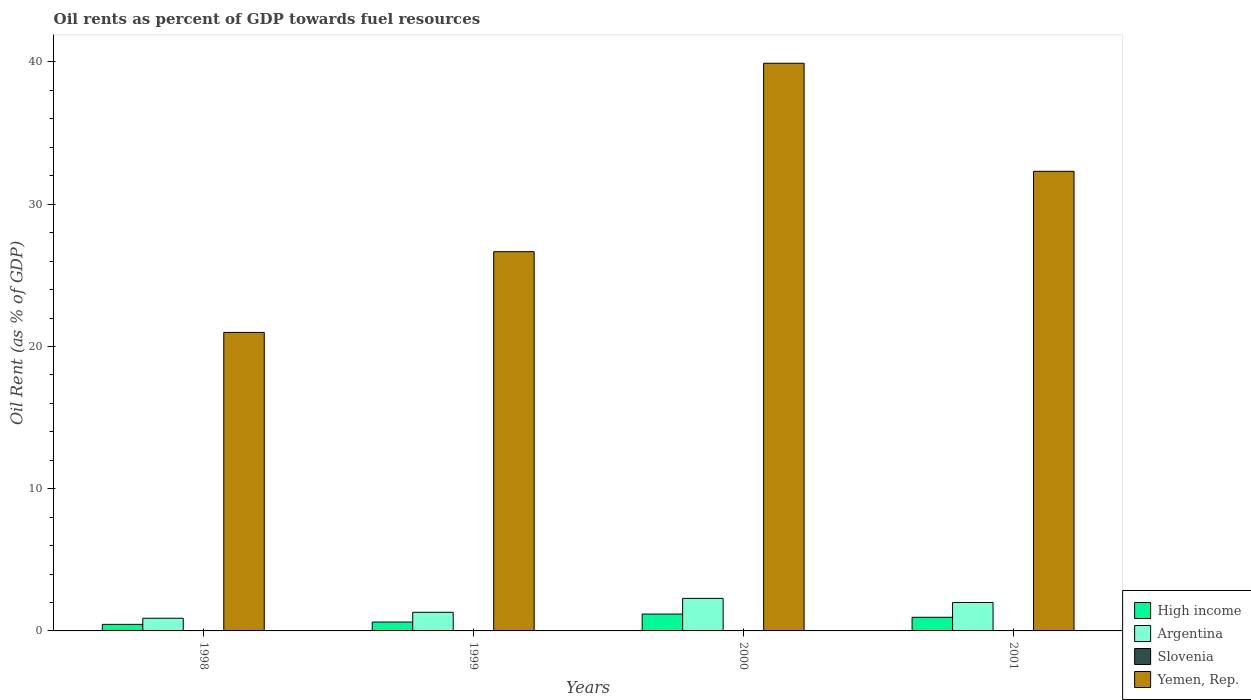How many different coloured bars are there?
Give a very brief answer. 4. How many groups of bars are there?
Your answer should be very brief. 4. Are the number of bars on each tick of the X-axis equal?
Offer a very short reply. Yes. How many bars are there on the 1st tick from the left?
Offer a terse response. 4. How many bars are there on the 3rd tick from the right?
Your answer should be very brief. 4. What is the oil rent in Slovenia in 1999?
Ensure brevity in your answer.  0. Across all years, what is the maximum oil rent in Yemen, Rep.?
Your answer should be very brief. 39.91. Across all years, what is the minimum oil rent in Yemen, Rep.?
Keep it short and to the point. 20.99. In which year was the oil rent in Slovenia minimum?
Keep it short and to the point. 1998. What is the total oil rent in High income in the graph?
Your answer should be compact. 3.23. What is the difference between the oil rent in Argentina in 1999 and that in 2001?
Provide a succinct answer. -0.69. What is the difference between the oil rent in Slovenia in 1998 and the oil rent in Yemen, Rep. in 1999?
Give a very brief answer. -26.66. What is the average oil rent in Yemen, Rep. per year?
Offer a terse response. 29.97. In the year 2000, what is the difference between the oil rent in Yemen, Rep. and oil rent in Argentina?
Provide a succinct answer. 37.62. What is the ratio of the oil rent in Yemen, Rep. in 1998 to that in 1999?
Provide a short and direct response. 0.79. Is the oil rent in Slovenia in 2000 less than that in 2001?
Offer a very short reply. No. What is the difference between the highest and the second highest oil rent in Yemen, Rep.?
Ensure brevity in your answer.  7.6. What is the difference between the highest and the lowest oil rent in Slovenia?
Your answer should be very brief. 0. In how many years, is the oil rent in High income greater than the average oil rent in High income taken over all years?
Your answer should be very brief. 2. What does the 4th bar from the right in 2000 represents?
Provide a short and direct response. High income. Are all the bars in the graph horizontal?
Give a very brief answer. No. How many years are there in the graph?
Offer a terse response. 4. How many legend labels are there?
Provide a succinct answer. 4. What is the title of the graph?
Offer a terse response. Oil rents as percent of GDP towards fuel resources. What is the label or title of the Y-axis?
Make the answer very short. Oil Rent (as % of GDP). What is the Oil Rent (as % of GDP) of High income in 1998?
Your answer should be compact. 0.46. What is the Oil Rent (as % of GDP) in Argentina in 1998?
Your answer should be compact. 0.89. What is the Oil Rent (as % of GDP) in Slovenia in 1998?
Provide a short and direct response. 0. What is the Oil Rent (as % of GDP) of Yemen, Rep. in 1998?
Your response must be concise. 20.99. What is the Oil Rent (as % of GDP) of High income in 1999?
Provide a succinct answer. 0.62. What is the Oil Rent (as % of GDP) of Argentina in 1999?
Your answer should be compact. 1.31. What is the Oil Rent (as % of GDP) of Slovenia in 1999?
Your response must be concise. 0. What is the Oil Rent (as % of GDP) of Yemen, Rep. in 1999?
Provide a short and direct response. 26.66. What is the Oil Rent (as % of GDP) in High income in 2000?
Your answer should be very brief. 1.19. What is the Oil Rent (as % of GDP) of Argentina in 2000?
Your answer should be compact. 2.29. What is the Oil Rent (as % of GDP) in Slovenia in 2000?
Your answer should be compact. 0. What is the Oil Rent (as % of GDP) in Yemen, Rep. in 2000?
Give a very brief answer. 39.91. What is the Oil Rent (as % of GDP) of High income in 2001?
Offer a very short reply. 0.96. What is the Oil Rent (as % of GDP) of Argentina in 2001?
Your answer should be very brief. 2. What is the Oil Rent (as % of GDP) of Slovenia in 2001?
Ensure brevity in your answer.  0. What is the Oil Rent (as % of GDP) in Yemen, Rep. in 2001?
Ensure brevity in your answer.  32.31. Across all years, what is the maximum Oil Rent (as % of GDP) of High income?
Give a very brief answer. 1.19. Across all years, what is the maximum Oil Rent (as % of GDP) in Argentina?
Provide a short and direct response. 2.29. Across all years, what is the maximum Oil Rent (as % of GDP) of Slovenia?
Provide a succinct answer. 0. Across all years, what is the maximum Oil Rent (as % of GDP) of Yemen, Rep.?
Keep it short and to the point. 39.91. Across all years, what is the minimum Oil Rent (as % of GDP) of High income?
Your answer should be very brief. 0.46. Across all years, what is the minimum Oil Rent (as % of GDP) in Argentina?
Offer a very short reply. 0.89. Across all years, what is the minimum Oil Rent (as % of GDP) of Slovenia?
Make the answer very short. 0. Across all years, what is the minimum Oil Rent (as % of GDP) of Yemen, Rep.?
Make the answer very short. 20.99. What is the total Oil Rent (as % of GDP) in High income in the graph?
Keep it short and to the point. 3.23. What is the total Oil Rent (as % of GDP) of Argentina in the graph?
Make the answer very short. 6.49. What is the total Oil Rent (as % of GDP) of Slovenia in the graph?
Offer a terse response. 0. What is the total Oil Rent (as % of GDP) of Yemen, Rep. in the graph?
Provide a succinct answer. 119.88. What is the difference between the Oil Rent (as % of GDP) in High income in 1998 and that in 1999?
Provide a short and direct response. -0.16. What is the difference between the Oil Rent (as % of GDP) of Argentina in 1998 and that in 1999?
Provide a short and direct response. -0.42. What is the difference between the Oil Rent (as % of GDP) of Slovenia in 1998 and that in 1999?
Your answer should be compact. -0. What is the difference between the Oil Rent (as % of GDP) in Yemen, Rep. in 1998 and that in 1999?
Ensure brevity in your answer.  -5.68. What is the difference between the Oil Rent (as % of GDP) in High income in 1998 and that in 2000?
Provide a succinct answer. -0.72. What is the difference between the Oil Rent (as % of GDP) in Argentina in 1998 and that in 2000?
Offer a very short reply. -1.4. What is the difference between the Oil Rent (as % of GDP) of Slovenia in 1998 and that in 2000?
Your response must be concise. -0. What is the difference between the Oil Rent (as % of GDP) in Yemen, Rep. in 1998 and that in 2000?
Provide a succinct answer. -18.92. What is the difference between the Oil Rent (as % of GDP) of High income in 1998 and that in 2001?
Offer a terse response. -0.5. What is the difference between the Oil Rent (as % of GDP) in Argentina in 1998 and that in 2001?
Offer a terse response. -1.11. What is the difference between the Oil Rent (as % of GDP) of Slovenia in 1998 and that in 2001?
Offer a terse response. -0. What is the difference between the Oil Rent (as % of GDP) in Yemen, Rep. in 1998 and that in 2001?
Make the answer very short. -11.33. What is the difference between the Oil Rent (as % of GDP) of High income in 1999 and that in 2000?
Ensure brevity in your answer.  -0.56. What is the difference between the Oil Rent (as % of GDP) of Argentina in 1999 and that in 2000?
Your answer should be compact. -0.98. What is the difference between the Oil Rent (as % of GDP) of Slovenia in 1999 and that in 2000?
Provide a succinct answer. -0. What is the difference between the Oil Rent (as % of GDP) of Yemen, Rep. in 1999 and that in 2000?
Your response must be concise. -13.25. What is the difference between the Oil Rent (as % of GDP) in High income in 1999 and that in 2001?
Keep it short and to the point. -0.33. What is the difference between the Oil Rent (as % of GDP) in Argentina in 1999 and that in 2001?
Your answer should be compact. -0.69. What is the difference between the Oil Rent (as % of GDP) of Slovenia in 1999 and that in 2001?
Your response must be concise. -0. What is the difference between the Oil Rent (as % of GDP) in Yemen, Rep. in 1999 and that in 2001?
Your response must be concise. -5.65. What is the difference between the Oil Rent (as % of GDP) of High income in 2000 and that in 2001?
Your answer should be very brief. 0.23. What is the difference between the Oil Rent (as % of GDP) in Argentina in 2000 and that in 2001?
Offer a terse response. 0.29. What is the difference between the Oil Rent (as % of GDP) in Slovenia in 2000 and that in 2001?
Offer a terse response. 0. What is the difference between the Oil Rent (as % of GDP) in Yemen, Rep. in 2000 and that in 2001?
Your response must be concise. 7.6. What is the difference between the Oil Rent (as % of GDP) in High income in 1998 and the Oil Rent (as % of GDP) in Argentina in 1999?
Provide a short and direct response. -0.85. What is the difference between the Oil Rent (as % of GDP) in High income in 1998 and the Oil Rent (as % of GDP) in Slovenia in 1999?
Ensure brevity in your answer.  0.46. What is the difference between the Oil Rent (as % of GDP) of High income in 1998 and the Oil Rent (as % of GDP) of Yemen, Rep. in 1999?
Your answer should be very brief. -26.2. What is the difference between the Oil Rent (as % of GDP) of Argentina in 1998 and the Oil Rent (as % of GDP) of Slovenia in 1999?
Provide a succinct answer. 0.89. What is the difference between the Oil Rent (as % of GDP) of Argentina in 1998 and the Oil Rent (as % of GDP) of Yemen, Rep. in 1999?
Ensure brevity in your answer.  -25.77. What is the difference between the Oil Rent (as % of GDP) of Slovenia in 1998 and the Oil Rent (as % of GDP) of Yemen, Rep. in 1999?
Offer a very short reply. -26.66. What is the difference between the Oil Rent (as % of GDP) of High income in 1998 and the Oil Rent (as % of GDP) of Argentina in 2000?
Your answer should be very brief. -1.83. What is the difference between the Oil Rent (as % of GDP) of High income in 1998 and the Oil Rent (as % of GDP) of Slovenia in 2000?
Your answer should be compact. 0.46. What is the difference between the Oil Rent (as % of GDP) of High income in 1998 and the Oil Rent (as % of GDP) of Yemen, Rep. in 2000?
Provide a succinct answer. -39.45. What is the difference between the Oil Rent (as % of GDP) in Argentina in 1998 and the Oil Rent (as % of GDP) in Slovenia in 2000?
Ensure brevity in your answer.  0.89. What is the difference between the Oil Rent (as % of GDP) of Argentina in 1998 and the Oil Rent (as % of GDP) of Yemen, Rep. in 2000?
Give a very brief answer. -39.02. What is the difference between the Oil Rent (as % of GDP) of Slovenia in 1998 and the Oil Rent (as % of GDP) of Yemen, Rep. in 2000?
Give a very brief answer. -39.91. What is the difference between the Oil Rent (as % of GDP) in High income in 1998 and the Oil Rent (as % of GDP) in Argentina in 2001?
Provide a short and direct response. -1.54. What is the difference between the Oil Rent (as % of GDP) in High income in 1998 and the Oil Rent (as % of GDP) in Slovenia in 2001?
Offer a terse response. 0.46. What is the difference between the Oil Rent (as % of GDP) in High income in 1998 and the Oil Rent (as % of GDP) in Yemen, Rep. in 2001?
Keep it short and to the point. -31.85. What is the difference between the Oil Rent (as % of GDP) of Argentina in 1998 and the Oil Rent (as % of GDP) of Slovenia in 2001?
Keep it short and to the point. 0.89. What is the difference between the Oil Rent (as % of GDP) of Argentina in 1998 and the Oil Rent (as % of GDP) of Yemen, Rep. in 2001?
Provide a short and direct response. -31.42. What is the difference between the Oil Rent (as % of GDP) of Slovenia in 1998 and the Oil Rent (as % of GDP) of Yemen, Rep. in 2001?
Keep it short and to the point. -32.31. What is the difference between the Oil Rent (as % of GDP) of High income in 1999 and the Oil Rent (as % of GDP) of Argentina in 2000?
Offer a terse response. -1.66. What is the difference between the Oil Rent (as % of GDP) in High income in 1999 and the Oil Rent (as % of GDP) in Slovenia in 2000?
Your response must be concise. 0.62. What is the difference between the Oil Rent (as % of GDP) in High income in 1999 and the Oil Rent (as % of GDP) in Yemen, Rep. in 2000?
Your answer should be very brief. -39.29. What is the difference between the Oil Rent (as % of GDP) in Argentina in 1999 and the Oil Rent (as % of GDP) in Slovenia in 2000?
Make the answer very short. 1.31. What is the difference between the Oil Rent (as % of GDP) of Argentina in 1999 and the Oil Rent (as % of GDP) of Yemen, Rep. in 2000?
Provide a short and direct response. -38.6. What is the difference between the Oil Rent (as % of GDP) in Slovenia in 1999 and the Oil Rent (as % of GDP) in Yemen, Rep. in 2000?
Offer a terse response. -39.91. What is the difference between the Oil Rent (as % of GDP) in High income in 1999 and the Oil Rent (as % of GDP) in Argentina in 2001?
Your answer should be compact. -1.38. What is the difference between the Oil Rent (as % of GDP) of High income in 1999 and the Oil Rent (as % of GDP) of Slovenia in 2001?
Provide a short and direct response. 0.62. What is the difference between the Oil Rent (as % of GDP) in High income in 1999 and the Oil Rent (as % of GDP) in Yemen, Rep. in 2001?
Provide a succinct answer. -31.69. What is the difference between the Oil Rent (as % of GDP) of Argentina in 1999 and the Oil Rent (as % of GDP) of Slovenia in 2001?
Your answer should be compact. 1.31. What is the difference between the Oil Rent (as % of GDP) in Argentina in 1999 and the Oil Rent (as % of GDP) in Yemen, Rep. in 2001?
Your answer should be very brief. -31. What is the difference between the Oil Rent (as % of GDP) in Slovenia in 1999 and the Oil Rent (as % of GDP) in Yemen, Rep. in 2001?
Offer a very short reply. -32.31. What is the difference between the Oil Rent (as % of GDP) in High income in 2000 and the Oil Rent (as % of GDP) in Argentina in 2001?
Your response must be concise. -0.81. What is the difference between the Oil Rent (as % of GDP) of High income in 2000 and the Oil Rent (as % of GDP) of Slovenia in 2001?
Offer a very short reply. 1.19. What is the difference between the Oil Rent (as % of GDP) in High income in 2000 and the Oil Rent (as % of GDP) in Yemen, Rep. in 2001?
Your answer should be very brief. -31.13. What is the difference between the Oil Rent (as % of GDP) in Argentina in 2000 and the Oil Rent (as % of GDP) in Slovenia in 2001?
Provide a short and direct response. 2.29. What is the difference between the Oil Rent (as % of GDP) in Argentina in 2000 and the Oil Rent (as % of GDP) in Yemen, Rep. in 2001?
Offer a terse response. -30.03. What is the difference between the Oil Rent (as % of GDP) of Slovenia in 2000 and the Oil Rent (as % of GDP) of Yemen, Rep. in 2001?
Keep it short and to the point. -32.31. What is the average Oil Rent (as % of GDP) in High income per year?
Your response must be concise. 0.81. What is the average Oil Rent (as % of GDP) of Argentina per year?
Make the answer very short. 1.62. What is the average Oil Rent (as % of GDP) in Yemen, Rep. per year?
Provide a succinct answer. 29.97. In the year 1998, what is the difference between the Oil Rent (as % of GDP) in High income and Oil Rent (as % of GDP) in Argentina?
Offer a very short reply. -0.43. In the year 1998, what is the difference between the Oil Rent (as % of GDP) in High income and Oil Rent (as % of GDP) in Slovenia?
Give a very brief answer. 0.46. In the year 1998, what is the difference between the Oil Rent (as % of GDP) in High income and Oil Rent (as % of GDP) in Yemen, Rep.?
Keep it short and to the point. -20.53. In the year 1998, what is the difference between the Oil Rent (as % of GDP) in Argentina and Oil Rent (as % of GDP) in Slovenia?
Ensure brevity in your answer.  0.89. In the year 1998, what is the difference between the Oil Rent (as % of GDP) in Argentina and Oil Rent (as % of GDP) in Yemen, Rep.?
Keep it short and to the point. -20.1. In the year 1998, what is the difference between the Oil Rent (as % of GDP) of Slovenia and Oil Rent (as % of GDP) of Yemen, Rep.?
Offer a terse response. -20.99. In the year 1999, what is the difference between the Oil Rent (as % of GDP) in High income and Oil Rent (as % of GDP) in Argentina?
Provide a short and direct response. -0.69. In the year 1999, what is the difference between the Oil Rent (as % of GDP) of High income and Oil Rent (as % of GDP) of Slovenia?
Ensure brevity in your answer.  0.62. In the year 1999, what is the difference between the Oil Rent (as % of GDP) in High income and Oil Rent (as % of GDP) in Yemen, Rep.?
Give a very brief answer. -26.04. In the year 1999, what is the difference between the Oil Rent (as % of GDP) of Argentina and Oil Rent (as % of GDP) of Slovenia?
Your answer should be compact. 1.31. In the year 1999, what is the difference between the Oil Rent (as % of GDP) in Argentina and Oil Rent (as % of GDP) in Yemen, Rep.?
Ensure brevity in your answer.  -25.35. In the year 1999, what is the difference between the Oil Rent (as % of GDP) of Slovenia and Oil Rent (as % of GDP) of Yemen, Rep.?
Provide a succinct answer. -26.66. In the year 2000, what is the difference between the Oil Rent (as % of GDP) in High income and Oil Rent (as % of GDP) in Argentina?
Make the answer very short. -1.1. In the year 2000, what is the difference between the Oil Rent (as % of GDP) in High income and Oil Rent (as % of GDP) in Slovenia?
Your answer should be compact. 1.19. In the year 2000, what is the difference between the Oil Rent (as % of GDP) in High income and Oil Rent (as % of GDP) in Yemen, Rep.?
Provide a short and direct response. -38.72. In the year 2000, what is the difference between the Oil Rent (as % of GDP) of Argentina and Oil Rent (as % of GDP) of Slovenia?
Your answer should be very brief. 2.29. In the year 2000, what is the difference between the Oil Rent (as % of GDP) in Argentina and Oil Rent (as % of GDP) in Yemen, Rep.?
Offer a terse response. -37.62. In the year 2000, what is the difference between the Oil Rent (as % of GDP) in Slovenia and Oil Rent (as % of GDP) in Yemen, Rep.?
Your answer should be very brief. -39.91. In the year 2001, what is the difference between the Oil Rent (as % of GDP) of High income and Oil Rent (as % of GDP) of Argentina?
Offer a very short reply. -1.04. In the year 2001, what is the difference between the Oil Rent (as % of GDP) of High income and Oil Rent (as % of GDP) of Slovenia?
Offer a very short reply. 0.96. In the year 2001, what is the difference between the Oil Rent (as % of GDP) of High income and Oil Rent (as % of GDP) of Yemen, Rep.?
Give a very brief answer. -31.36. In the year 2001, what is the difference between the Oil Rent (as % of GDP) of Argentina and Oil Rent (as % of GDP) of Slovenia?
Provide a short and direct response. 2. In the year 2001, what is the difference between the Oil Rent (as % of GDP) of Argentina and Oil Rent (as % of GDP) of Yemen, Rep.?
Provide a succinct answer. -30.31. In the year 2001, what is the difference between the Oil Rent (as % of GDP) of Slovenia and Oil Rent (as % of GDP) of Yemen, Rep.?
Offer a terse response. -32.31. What is the ratio of the Oil Rent (as % of GDP) of High income in 1998 to that in 1999?
Give a very brief answer. 0.74. What is the ratio of the Oil Rent (as % of GDP) in Argentina in 1998 to that in 1999?
Provide a succinct answer. 0.68. What is the ratio of the Oil Rent (as % of GDP) in Slovenia in 1998 to that in 1999?
Offer a very short reply. 0.69. What is the ratio of the Oil Rent (as % of GDP) of Yemen, Rep. in 1998 to that in 1999?
Your answer should be compact. 0.79. What is the ratio of the Oil Rent (as % of GDP) of High income in 1998 to that in 2000?
Provide a short and direct response. 0.39. What is the ratio of the Oil Rent (as % of GDP) of Argentina in 1998 to that in 2000?
Your response must be concise. 0.39. What is the ratio of the Oil Rent (as % of GDP) of Slovenia in 1998 to that in 2000?
Your answer should be compact. 0.33. What is the ratio of the Oil Rent (as % of GDP) in Yemen, Rep. in 1998 to that in 2000?
Provide a short and direct response. 0.53. What is the ratio of the Oil Rent (as % of GDP) of High income in 1998 to that in 2001?
Provide a short and direct response. 0.48. What is the ratio of the Oil Rent (as % of GDP) in Argentina in 1998 to that in 2001?
Give a very brief answer. 0.45. What is the ratio of the Oil Rent (as % of GDP) of Slovenia in 1998 to that in 2001?
Give a very brief answer. 0.61. What is the ratio of the Oil Rent (as % of GDP) in Yemen, Rep. in 1998 to that in 2001?
Provide a short and direct response. 0.65. What is the ratio of the Oil Rent (as % of GDP) of High income in 1999 to that in 2000?
Make the answer very short. 0.53. What is the ratio of the Oil Rent (as % of GDP) of Argentina in 1999 to that in 2000?
Ensure brevity in your answer.  0.57. What is the ratio of the Oil Rent (as % of GDP) in Slovenia in 1999 to that in 2000?
Your response must be concise. 0.49. What is the ratio of the Oil Rent (as % of GDP) in Yemen, Rep. in 1999 to that in 2000?
Your answer should be very brief. 0.67. What is the ratio of the Oil Rent (as % of GDP) in High income in 1999 to that in 2001?
Offer a terse response. 0.65. What is the ratio of the Oil Rent (as % of GDP) in Argentina in 1999 to that in 2001?
Provide a short and direct response. 0.66. What is the ratio of the Oil Rent (as % of GDP) in Slovenia in 1999 to that in 2001?
Your response must be concise. 0.88. What is the ratio of the Oil Rent (as % of GDP) in Yemen, Rep. in 1999 to that in 2001?
Your response must be concise. 0.83. What is the ratio of the Oil Rent (as % of GDP) of High income in 2000 to that in 2001?
Keep it short and to the point. 1.24. What is the ratio of the Oil Rent (as % of GDP) of Argentina in 2000 to that in 2001?
Your answer should be very brief. 1.14. What is the ratio of the Oil Rent (as % of GDP) of Slovenia in 2000 to that in 2001?
Give a very brief answer. 1.81. What is the ratio of the Oil Rent (as % of GDP) of Yemen, Rep. in 2000 to that in 2001?
Provide a short and direct response. 1.24. What is the difference between the highest and the second highest Oil Rent (as % of GDP) of High income?
Your answer should be very brief. 0.23. What is the difference between the highest and the second highest Oil Rent (as % of GDP) of Argentina?
Ensure brevity in your answer.  0.29. What is the difference between the highest and the second highest Oil Rent (as % of GDP) of Yemen, Rep.?
Provide a short and direct response. 7.6. What is the difference between the highest and the lowest Oil Rent (as % of GDP) of High income?
Ensure brevity in your answer.  0.72. What is the difference between the highest and the lowest Oil Rent (as % of GDP) in Argentina?
Your response must be concise. 1.4. What is the difference between the highest and the lowest Oil Rent (as % of GDP) in Slovenia?
Make the answer very short. 0. What is the difference between the highest and the lowest Oil Rent (as % of GDP) of Yemen, Rep.?
Provide a short and direct response. 18.92. 